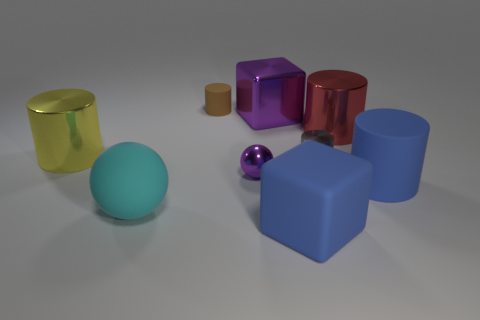Subtract all blue cylinders. How many cylinders are left? 4 Subtract all blue cylinders. How many cylinders are left? 4 Subtract all purple cylinders. Subtract all gray balls. How many cylinders are left? 5 Add 1 purple cubes. How many objects exist? 10 Subtract all blocks. How many objects are left? 7 Subtract 0 blue spheres. How many objects are left? 9 Subtract all shiny blocks. Subtract all big rubber cubes. How many objects are left? 7 Add 8 big purple metal cubes. How many big purple metal cubes are left? 9 Add 1 big objects. How many big objects exist? 7 